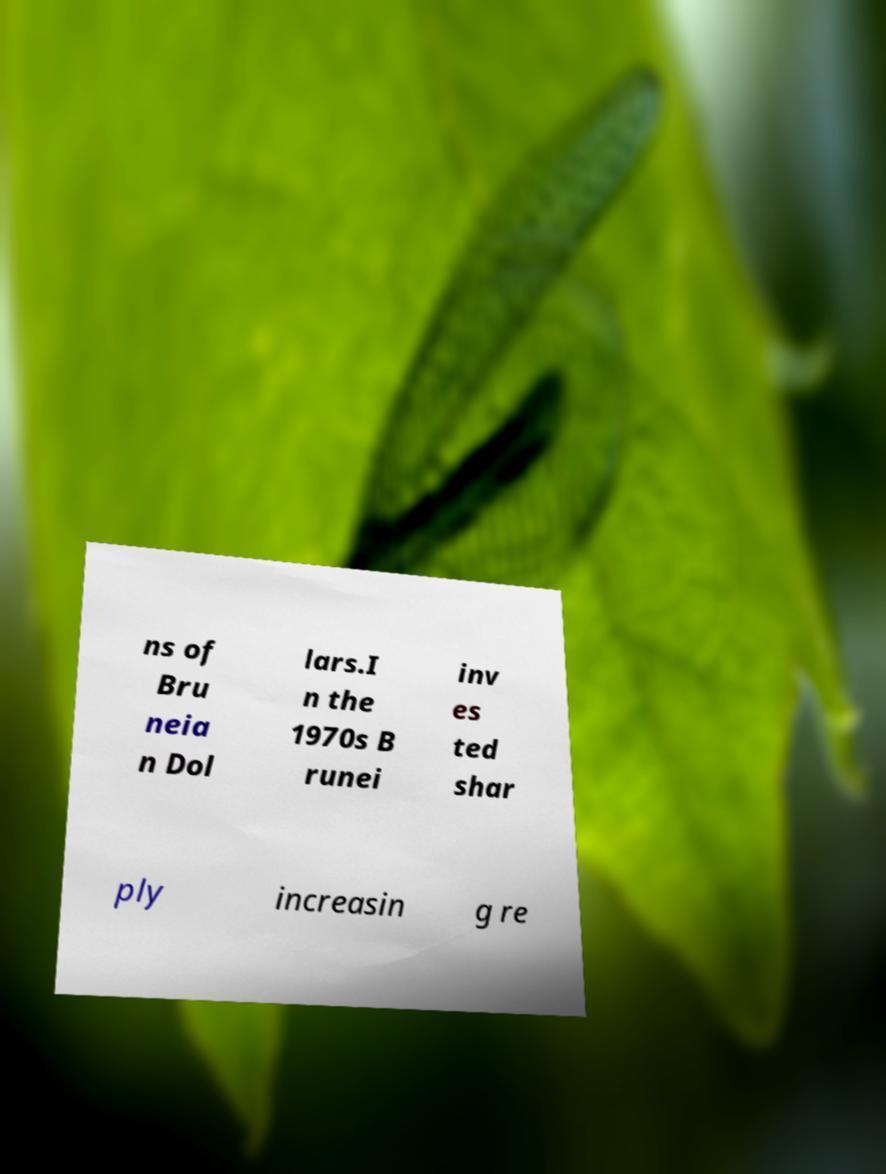Please identify and transcribe the text found in this image. ns of Bru neia n Dol lars.I n the 1970s B runei inv es ted shar ply increasin g re 